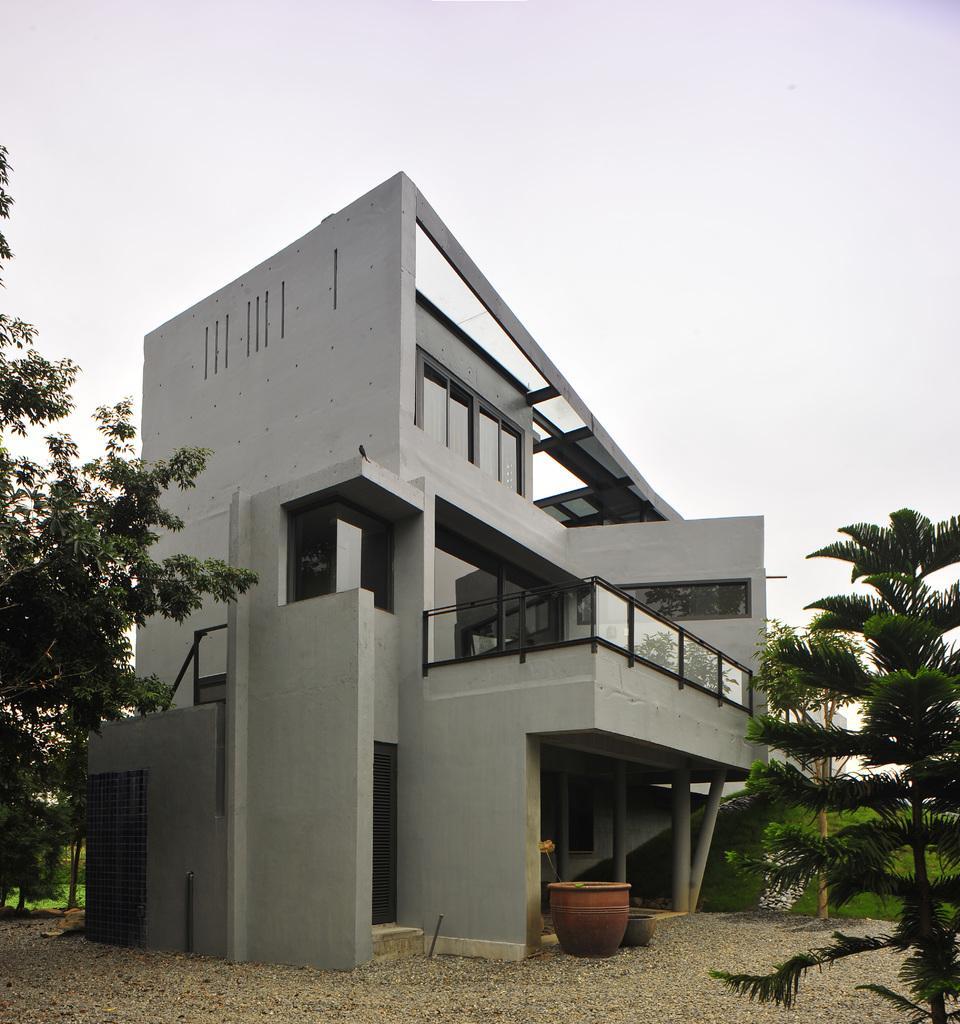In one or two sentences, can you explain what this image depicts? In the foreground of this image, on the right there is a tree. In the background, there is a building, a drum like an object, the ground and a tree. On the top, there is the sky. 